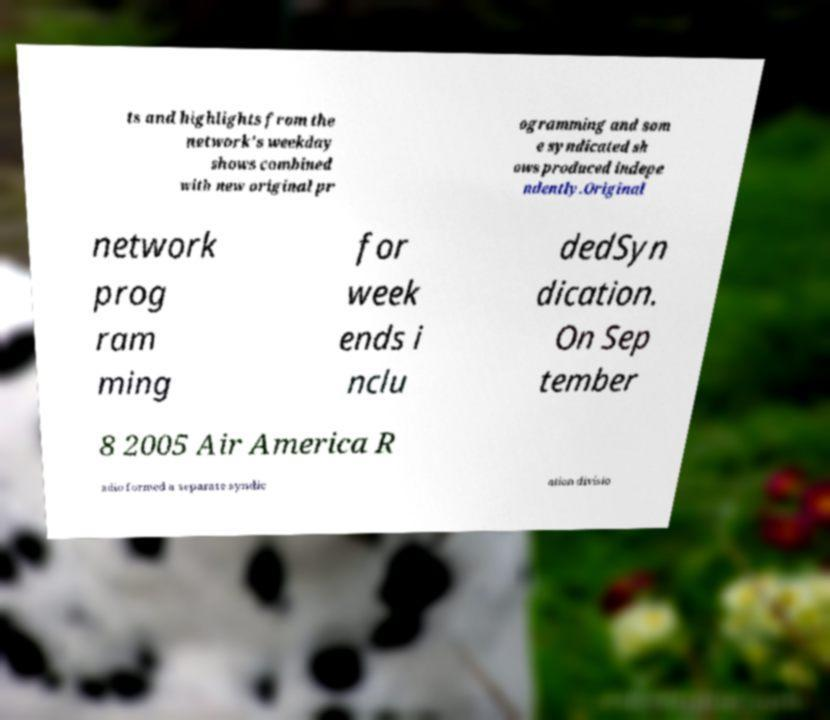There's text embedded in this image that I need extracted. Can you transcribe it verbatim? ts and highlights from the network's weekday shows combined with new original pr ogramming and som e syndicated sh ows produced indepe ndently.Original network prog ram ming for week ends i nclu dedSyn dication. On Sep tember 8 2005 Air America R adio formed a separate syndic ation divisio 